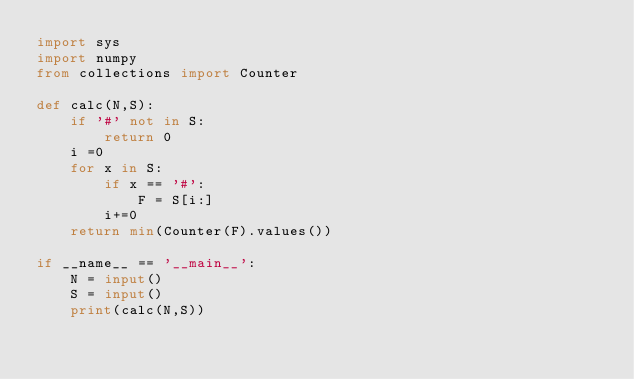<code> <loc_0><loc_0><loc_500><loc_500><_Python_>import sys
import numpy
from collections import Counter

def calc(N,S):
    if '#' not in S:
        return 0
    i =0
    for x in S:
        if x == '#':
            F = S[i:]
        i+=0
    return min(Counter(F).values())

if __name__ == '__main__':
    N = input()
    S = input()
    print(calc(N,S))</code> 